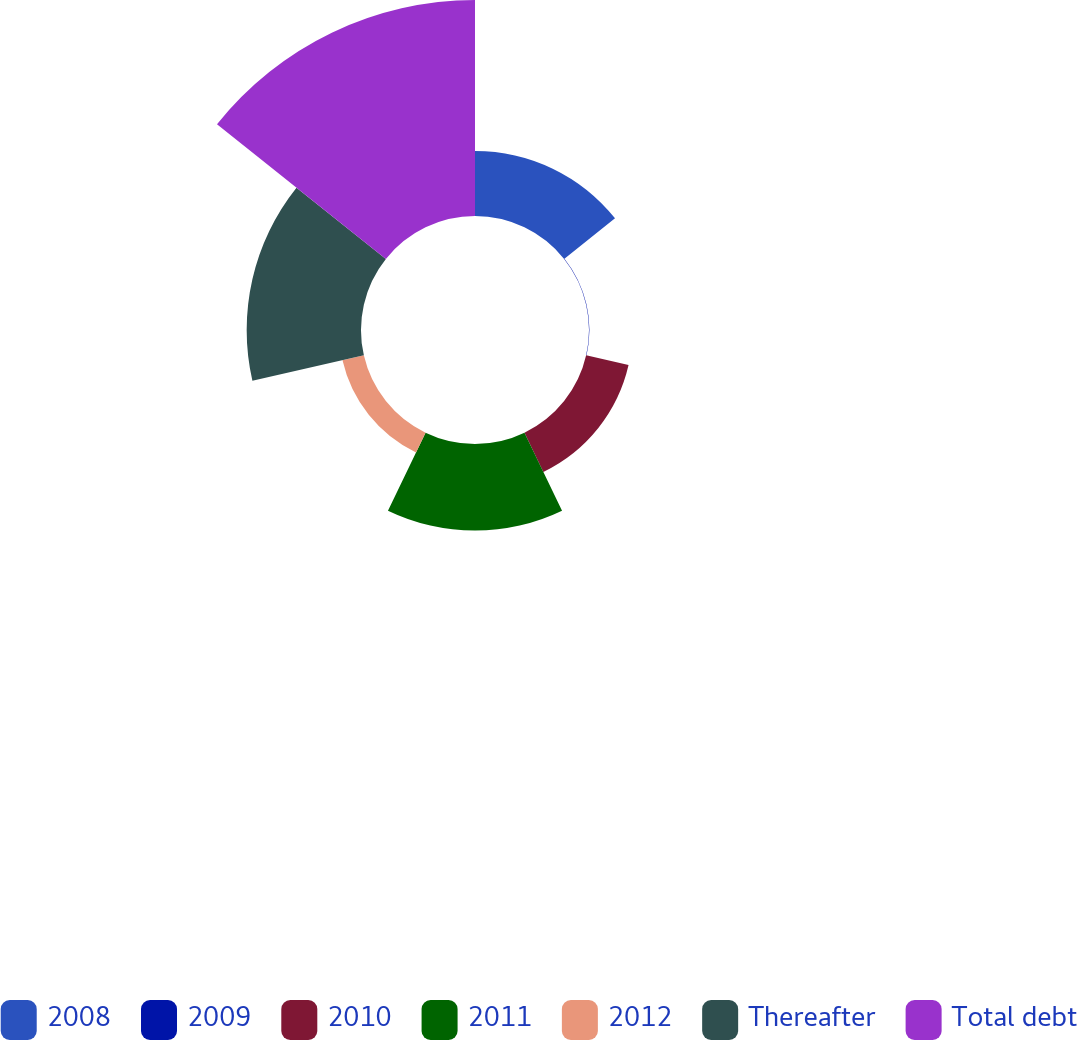Convert chart. <chart><loc_0><loc_0><loc_500><loc_500><pie_chart><fcel>2008<fcel>2009<fcel>2010<fcel>2011<fcel>2012<fcel>Thereafter<fcel>Total debt<nl><fcel>11.88%<fcel>0.07%<fcel>7.94%<fcel>15.81%<fcel>4.0%<fcel>20.87%<fcel>39.43%<nl></chart> 